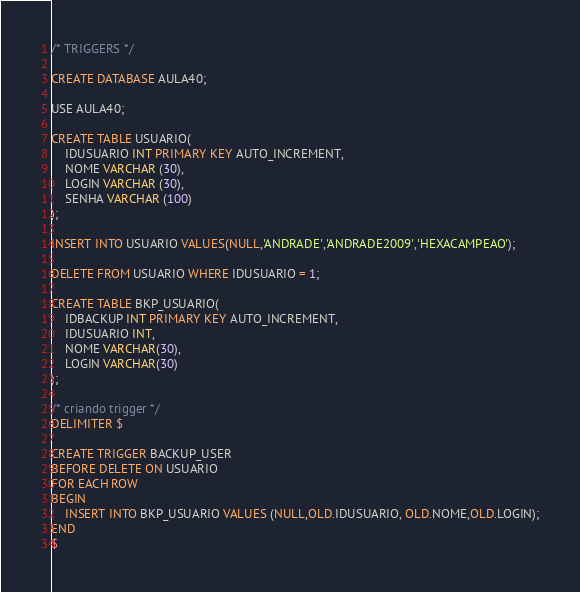Convert code to text. <code><loc_0><loc_0><loc_500><loc_500><_SQL_>/* TRIGGERS */ 

CREATE DATABASE AULA40;

USE AULA40;

CREATE TABLE USUARIO(
	IDUSUARIO INT PRIMARY KEY AUTO_INCREMENT,
	NOME VARCHAR (30),
	LOGIN VARCHAR (30),
	SENHA VARCHAR (100)
);

INSERT INTO USUARIO VALUES(NULL,'ANDRADE','ANDRADE2009','HEXACAMPEAO');

DELETE FROM USUARIO WHERE IDUSUARIO = 1;

CREATE TABLE BKP_USUARIO(
	IDBACKUP INT PRIMARY KEY AUTO_INCREMENT,
	IDUSUARIO INT,
	NOME VARCHAR(30),
	LOGIN VARCHAR(30)
);

/* criando trigger */ 
DELIMITER $ 

CREATE TRIGGER BACKUP_USER 
BEFORE DELETE ON USUARIO 
FOR EACH ROW 
BEGIN 
	INSERT INTO BKP_USUARIO VALUES (NULL,OLD.IDUSUARIO, OLD.NOME,OLD.LOGIN);
END
$</code> 